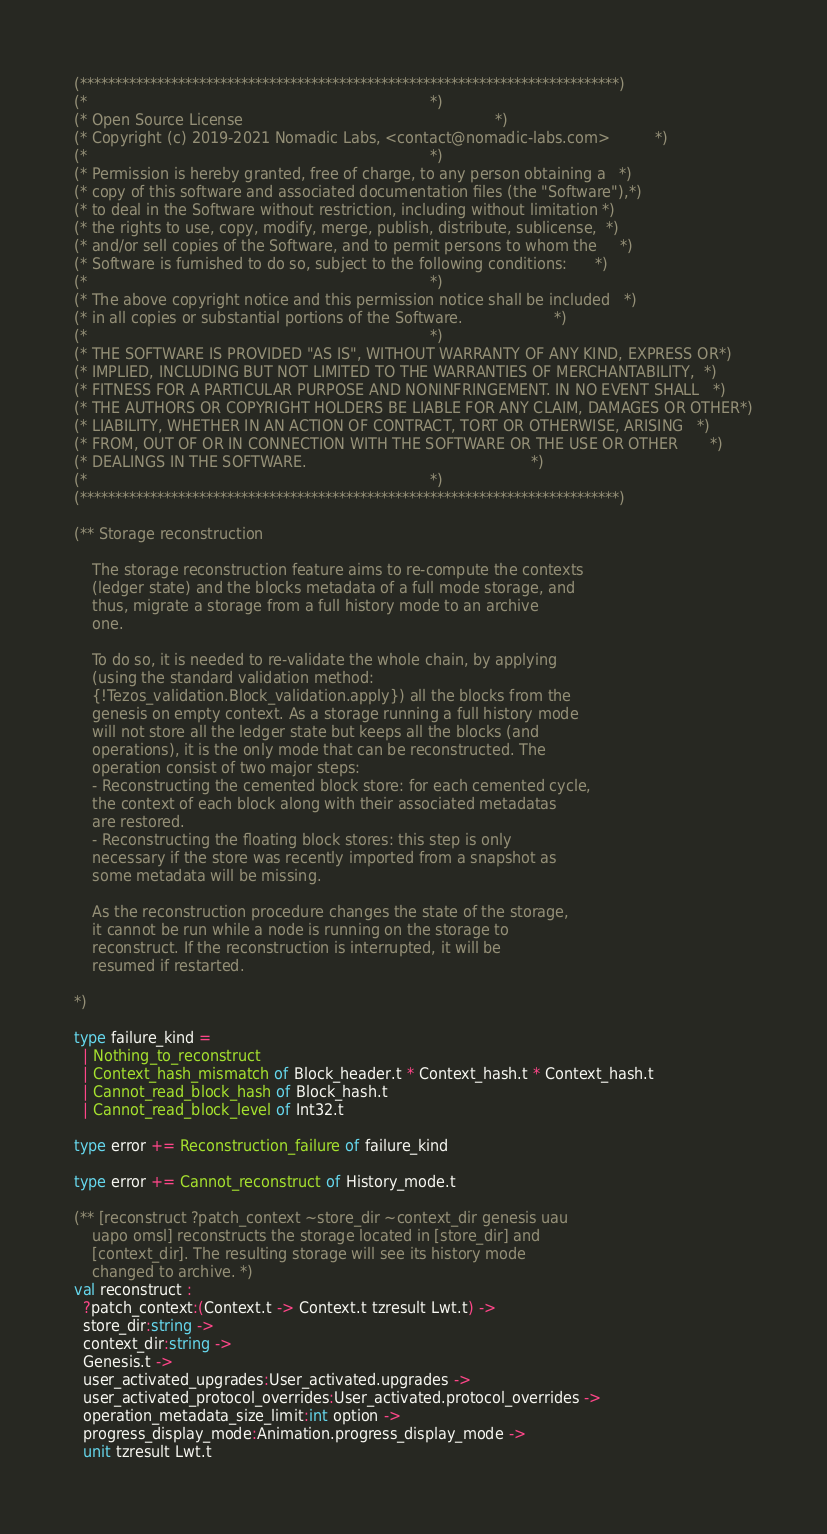Convert code to text. <code><loc_0><loc_0><loc_500><loc_500><_OCaml_>(*****************************************************************************)
(*                                                                           *)
(* Open Source License                                                       *)
(* Copyright (c) 2019-2021 Nomadic Labs, <contact@nomadic-labs.com>          *)
(*                                                                           *)
(* Permission is hereby granted, free of charge, to any person obtaining a   *)
(* copy of this software and associated documentation files (the "Software"),*)
(* to deal in the Software without restriction, including without limitation *)
(* the rights to use, copy, modify, merge, publish, distribute, sublicense,  *)
(* and/or sell copies of the Software, and to permit persons to whom the     *)
(* Software is furnished to do so, subject to the following conditions:      *)
(*                                                                           *)
(* The above copyright notice and this permission notice shall be included   *)
(* in all copies or substantial portions of the Software.                    *)
(*                                                                           *)
(* THE SOFTWARE IS PROVIDED "AS IS", WITHOUT WARRANTY OF ANY KIND, EXPRESS OR*)
(* IMPLIED, INCLUDING BUT NOT LIMITED TO THE WARRANTIES OF MERCHANTABILITY,  *)
(* FITNESS FOR A PARTICULAR PURPOSE AND NONINFRINGEMENT. IN NO EVENT SHALL   *)
(* THE AUTHORS OR COPYRIGHT HOLDERS BE LIABLE FOR ANY CLAIM, DAMAGES OR OTHER*)
(* LIABILITY, WHETHER IN AN ACTION OF CONTRACT, TORT OR OTHERWISE, ARISING   *)
(* FROM, OUT OF OR IN CONNECTION WITH THE SOFTWARE OR THE USE OR OTHER       *)
(* DEALINGS IN THE SOFTWARE.                                                 *)
(*                                                                           *)
(*****************************************************************************)

(** Storage reconstruction

    The storage reconstruction feature aims to re-compute the contexts
    (ledger state) and the blocks metadata of a full mode storage, and
    thus, migrate a storage from a full history mode to an archive
    one.

    To do so, it is needed to re-validate the whole chain, by applying
    (using the standard validation method:
    {!Tezos_validation.Block_validation.apply}) all the blocks from the
    genesis on empty context. As a storage running a full history mode
    will not store all the ledger state but keeps all the blocks (and
    operations), it is the only mode that can be reconstructed. The
    operation consist of two major steps:
    - Reconstructing the cemented block store: for each cemented cycle,
    the context of each block along with their associated metadatas
    are restored.
    - Reconstructing the floating block stores: this step is only
    necessary if the store was recently imported from a snapshot as
    some metadata will be missing.

    As the reconstruction procedure changes the state of the storage,
    it cannot be run while a node is running on the storage to
    reconstruct. If the reconstruction is interrupted, it will be
    resumed if restarted.

*)

type failure_kind =
  | Nothing_to_reconstruct
  | Context_hash_mismatch of Block_header.t * Context_hash.t * Context_hash.t
  | Cannot_read_block_hash of Block_hash.t
  | Cannot_read_block_level of Int32.t

type error += Reconstruction_failure of failure_kind

type error += Cannot_reconstruct of History_mode.t

(** [reconstruct ?patch_context ~store_dir ~context_dir genesis uau
    uapo omsl] reconstructs the storage located in [store_dir] and
    [context_dir]. The resulting storage will see its history mode
    changed to archive. *)
val reconstruct :
  ?patch_context:(Context.t -> Context.t tzresult Lwt.t) ->
  store_dir:string ->
  context_dir:string ->
  Genesis.t ->
  user_activated_upgrades:User_activated.upgrades ->
  user_activated_protocol_overrides:User_activated.protocol_overrides ->
  operation_metadata_size_limit:int option ->
  progress_display_mode:Animation.progress_display_mode ->
  unit tzresult Lwt.t
</code> 